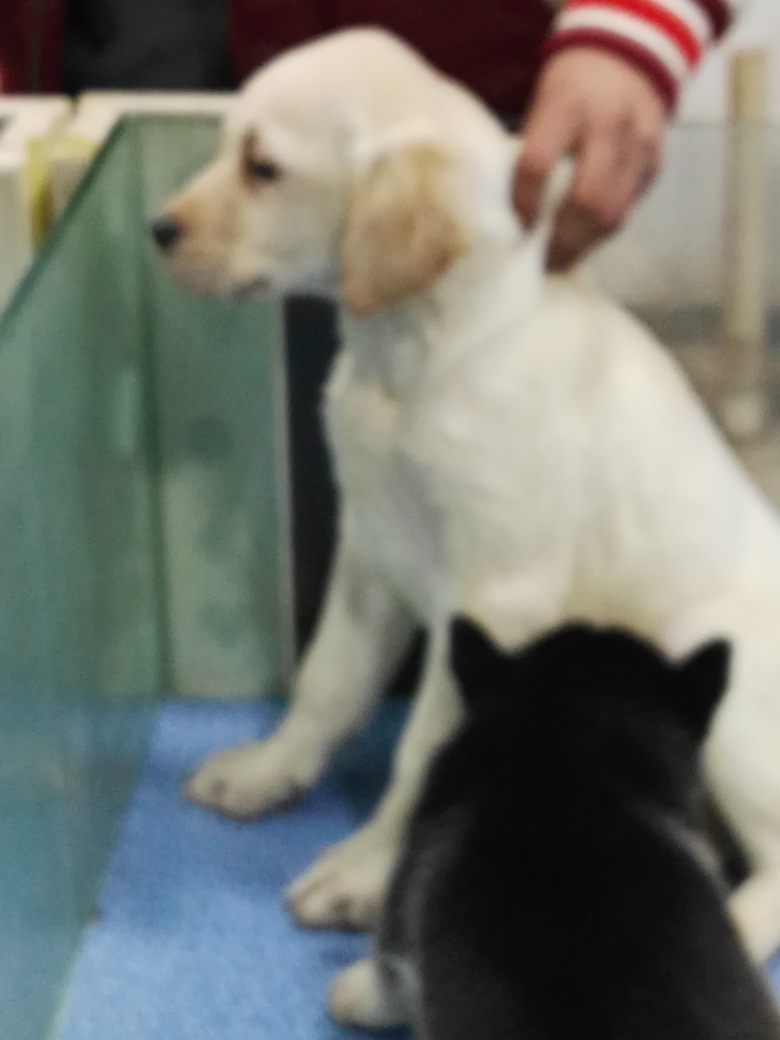Can you describe the animals in the image? Certainly! The image appears to show two dogs. One dog is white with a coat that seems soft and a bit wavy, possibly a young Labrador or a similar breed. It's facing to the side and its gaze is directed away from the camera. The second dog is primarily not visible, but it seems to have a dark coat and is closer to the camera. The setting seems like an indoor facility with a blue flooring, like a veterinary office or pet store. 